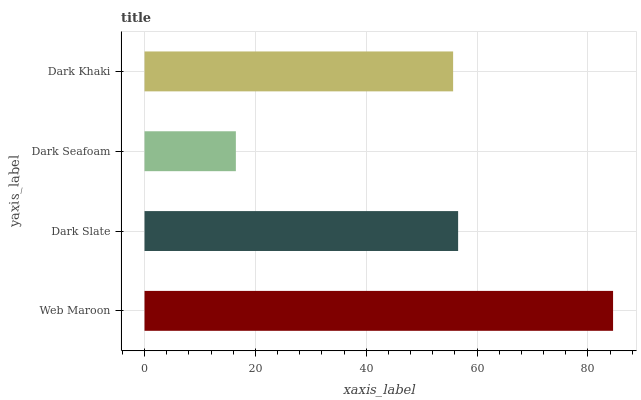Is Dark Seafoam the minimum?
Answer yes or no. Yes. Is Web Maroon the maximum?
Answer yes or no. Yes. Is Dark Slate the minimum?
Answer yes or no. No. Is Dark Slate the maximum?
Answer yes or no. No. Is Web Maroon greater than Dark Slate?
Answer yes or no. Yes. Is Dark Slate less than Web Maroon?
Answer yes or no. Yes. Is Dark Slate greater than Web Maroon?
Answer yes or no. No. Is Web Maroon less than Dark Slate?
Answer yes or no. No. Is Dark Slate the high median?
Answer yes or no. Yes. Is Dark Khaki the low median?
Answer yes or no. Yes. Is Dark Seafoam the high median?
Answer yes or no. No. Is Dark Seafoam the low median?
Answer yes or no. No. 